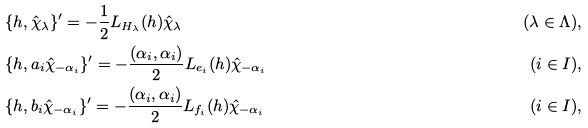<formula> <loc_0><loc_0><loc_500><loc_500>& \{ h , \hat { \chi } _ { \lambda } \} ^ { \prime } = - \frac { 1 } { 2 } L _ { H _ { \lambda } } ( h ) \hat { \chi } _ { \lambda } & ( \lambda \in \Lambda ) , \\ & \{ h , a _ { i } \hat { \chi } _ { - \alpha _ { i } } \} ^ { \prime } = - \frac { ( \alpha _ { i } , \alpha _ { i } ) } 2 L _ { e _ { i } } ( h ) \hat { \chi } _ { - \alpha _ { i } } & ( i \in I ) , \\ & \{ h , b _ { i } \hat { \chi } _ { - \alpha _ { i } } \} ^ { \prime } = - \frac { ( \alpha _ { i } , \alpha _ { i } ) } 2 L _ { f _ { i } } ( h ) \hat { \chi } _ { - \alpha _ { i } } & ( i \in I ) ,</formula> 